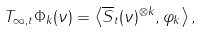<formula> <loc_0><loc_0><loc_500><loc_500>\label [ I e q ] { e q \colon T i n f t y t p h i k } T _ { \infty , t } \Phi _ { k } ( \nu ) = \left \langle \overline { S } _ { t } ( \nu ) ^ { \otimes k } , \varphi _ { k } \right \rangle ,</formula> 